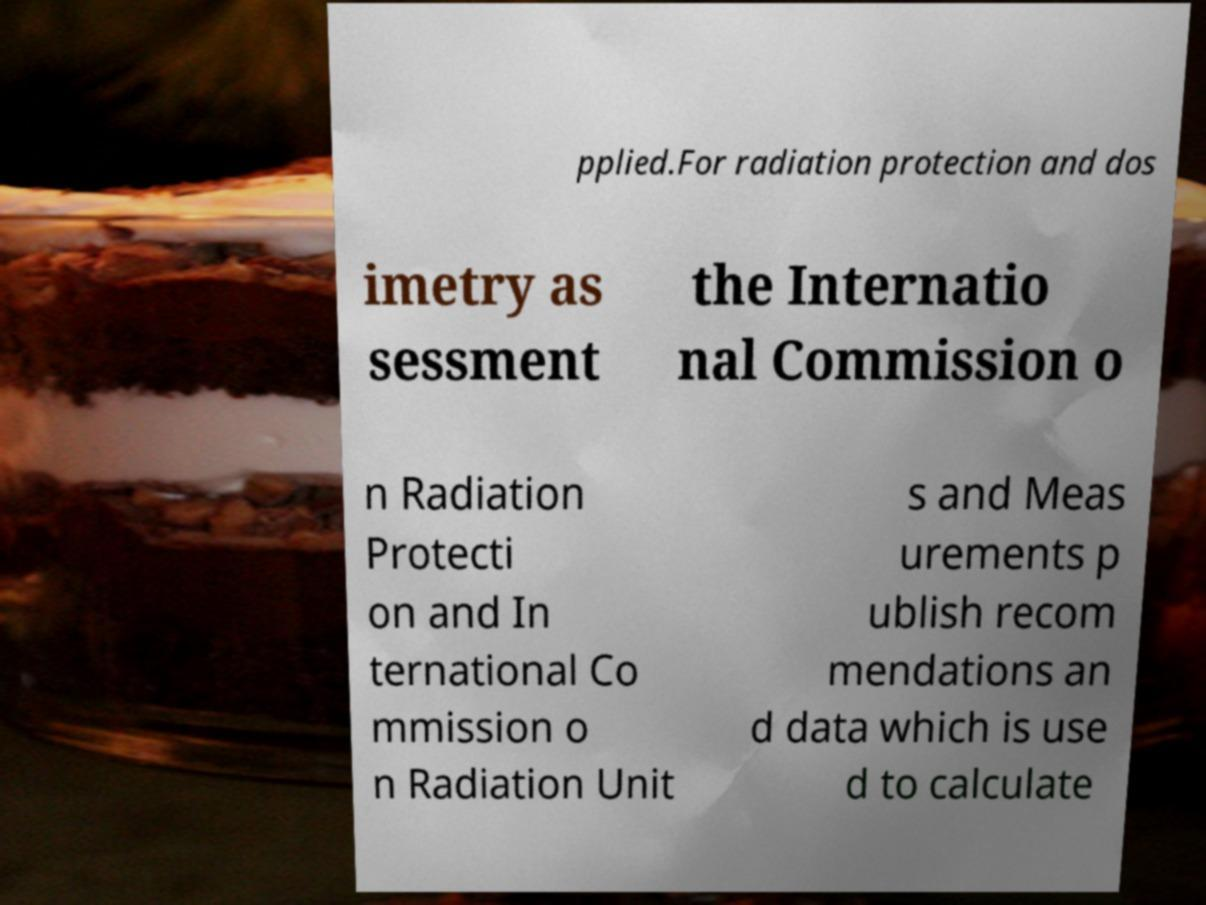Can you accurately transcribe the text from the provided image for me? pplied.For radiation protection and dos imetry as sessment the Internatio nal Commission o n Radiation Protecti on and In ternational Co mmission o n Radiation Unit s and Meas urements p ublish recom mendations an d data which is use d to calculate 